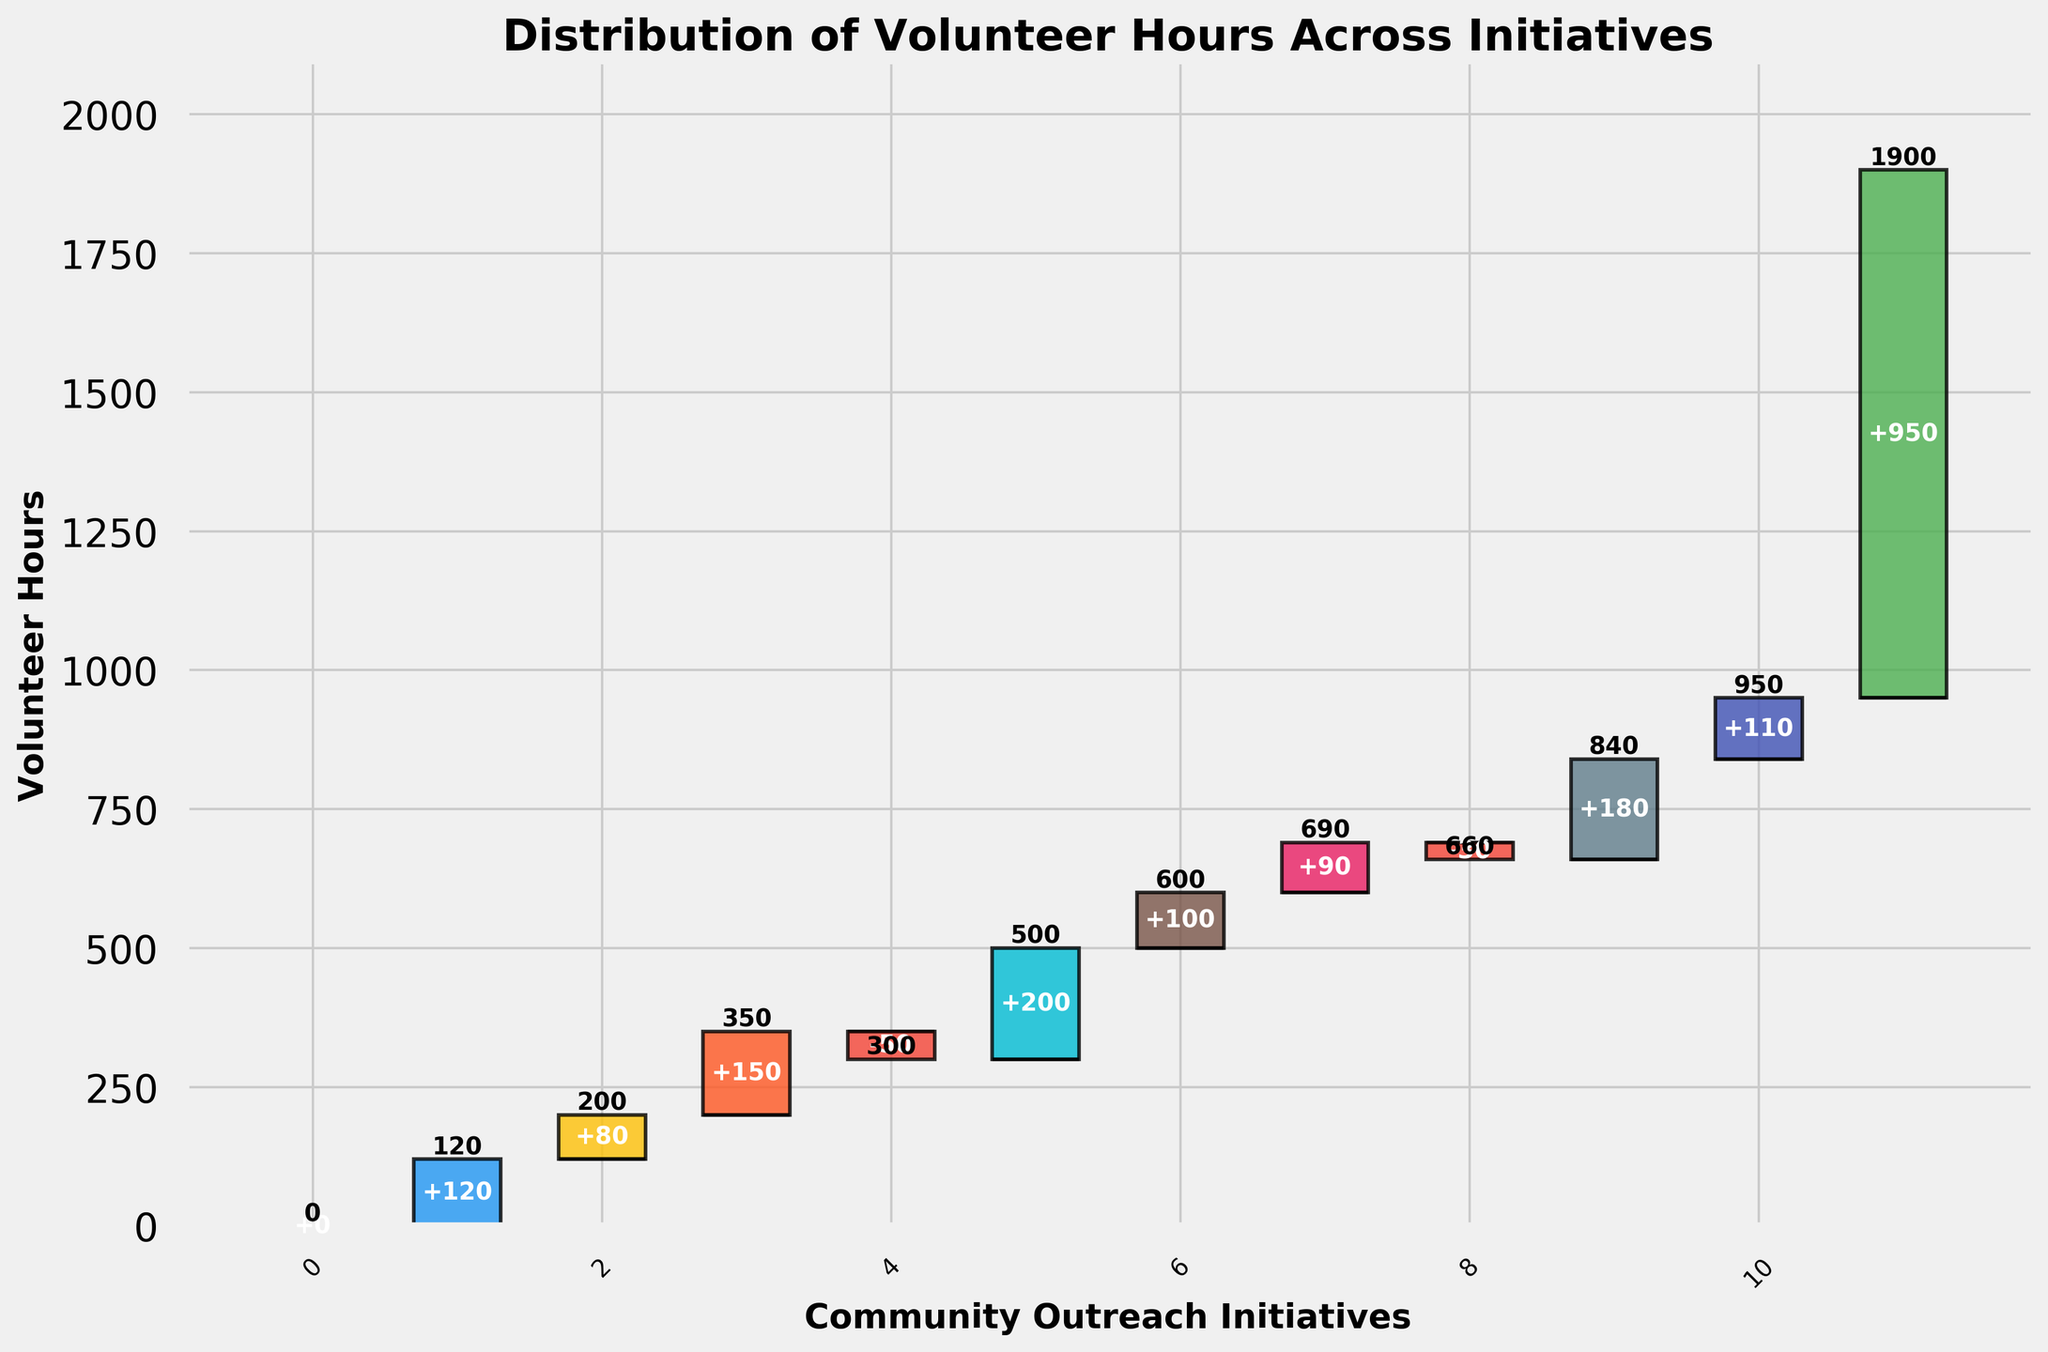What is the title of the figure? The title of the figure is usually displayed at the top of the chart. By looking at the top-most part of the figure, you can see the title "Distribution of Volunteer Hours Across Initiatives".
Answer: Distribution of Volunteer Hours Across Initiatives What are the two axes labeled? The X-axis label can be found at the bottom underneath the tick labels and the Y-axis label can be found on the left side of the plot. The X-axis label is "Community Outreach Initiatives" and the Y-axis label is "Volunteer Hours".
Answer: Community Outreach Initiatives, Volunteer Hours How many community outreach initiatives are represented in the figure? Count the number of unique labels on the X-axis, excluding the "Start" and "End" labels. There are 9 outreach initiatives represented.
Answer: 9 Which initiative had the highest positive volunteer hours contribution? Look for the tallest positive bar in the figure, which represents the highest positive contribution. The tallest positive bar corresponds to the "Homeless Shelter" initiative.
Answer: Homeless Shelter What is the cumulative volunteer hours at the end of the year? The final cumulative value can be found at the last bar labeled "End". The figure indicates this value is 950 hours.
Answer: 950 hours By how much did the Environmental Cleanup initiative decrease volunteer hours? Find the "Environmental Cleanup" bar and note its height in the negative direction. The label on the bar shows a decrease of 50 hours.
Answer: 50 hours What is the sum of the volunteer hours contributed by the Food Bank and Youth Mentoring initiatives? Look at the heights of the "Food Bank" and "Youth Mentoring" bars, which are 120 hours and 150 hours, respectively. Adding these values gives 120 + 150 = 270 hours.
Answer: 270 hours Which initiatives resulted in a decrease in volunteer hours? Identify the bars that extend downwards. The bars for "Environmental Cleanup" and "Community Garden" represent decreases.
Answer: Environmental Cleanup, Community Garden How does the volunteer hours contribution of Senior Companionship compare to Social Justice Advocacy? Compare the heights of the "Senior Companionship" and "Social Justice Advocacy" bars. "Senior Companionship" has a height of 100 hours, whereas "Social Justice Advocacy" has a height of 110 hours. Therefore, "Social Justice Advocacy" has a slightly higher contribution.
Answer: Social Justice Advocacy has higher contribution What is the net change in volunteer hours from the beginning to the end of the Holiday Meal Service initiative? The initial cumulative hours before the Holiday Meal Service and the final cumulative hours after should be compared. The cumulative hours before the Holiday Meal Service are 470, and the cumulative hours after are 650. The net change is 650 - 470 = 180 hours.
Answer: 180 hours 